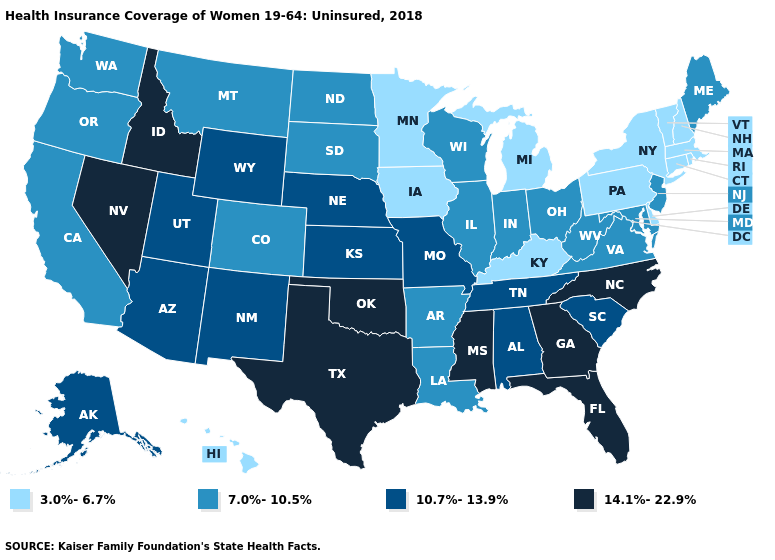Name the states that have a value in the range 14.1%-22.9%?
Concise answer only. Florida, Georgia, Idaho, Mississippi, Nevada, North Carolina, Oklahoma, Texas. What is the value of Arkansas?
Give a very brief answer. 7.0%-10.5%. Does Colorado have the same value as North Carolina?
Give a very brief answer. No. Does Georgia have the highest value in the USA?
Give a very brief answer. Yes. Does Texas have the same value as Mississippi?
Keep it brief. Yes. Among the states that border Delaware , does Pennsylvania have the highest value?
Be succinct. No. Name the states that have a value in the range 3.0%-6.7%?
Quick response, please. Connecticut, Delaware, Hawaii, Iowa, Kentucky, Massachusetts, Michigan, Minnesota, New Hampshire, New York, Pennsylvania, Rhode Island, Vermont. Does Nevada have a higher value than Kansas?
Quick response, please. Yes. Among the states that border New York , does New Jersey have the highest value?
Keep it brief. Yes. Name the states that have a value in the range 3.0%-6.7%?
Keep it brief. Connecticut, Delaware, Hawaii, Iowa, Kentucky, Massachusetts, Michigan, Minnesota, New Hampshire, New York, Pennsylvania, Rhode Island, Vermont. Does Colorado have the highest value in the USA?
Answer briefly. No. What is the value of Florida?
Quick response, please. 14.1%-22.9%. Name the states that have a value in the range 14.1%-22.9%?
Keep it brief. Florida, Georgia, Idaho, Mississippi, Nevada, North Carolina, Oklahoma, Texas. Does Washington have the highest value in the West?
Concise answer only. No. 